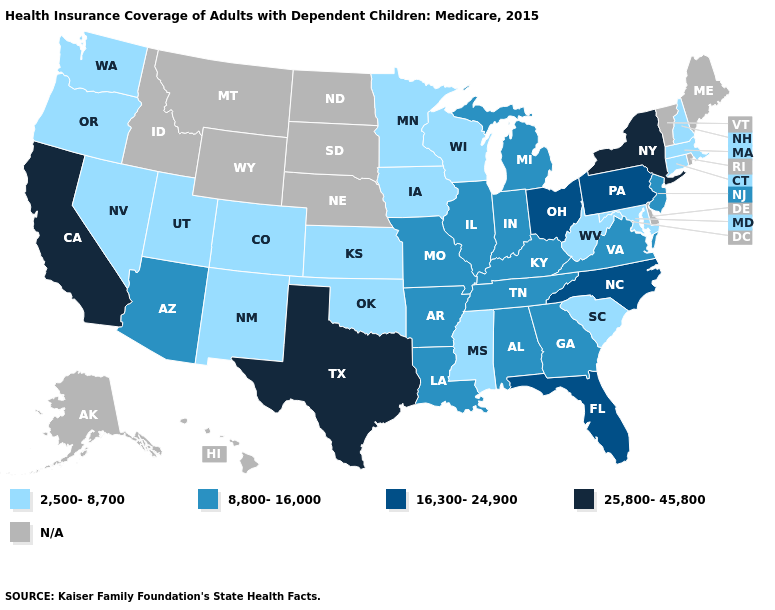How many symbols are there in the legend?
Give a very brief answer. 5. Among the states that border Utah , which have the highest value?
Short answer required. Arizona. Which states have the lowest value in the South?
Quick response, please. Maryland, Mississippi, Oklahoma, South Carolina, West Virginia. Name the states that have a value in the range N/A?
Keep it brief. Alaska, Delaware, Hawaii, Idaho, Maine, Montana, Nebraska, North Dakota, Rhode Island, South Dakota, Vermont, Wyoming. What is the value of West Virginia?
Write a very short answer. 2,500-8,700. What is the value of Colorado?
Quick response, please. 2,500-8,700. Which states have the lowest value in the USA?
Give a very brief answer. Colorado, Connecticut, Iowa, Kansas, Maryland, Massachusetts, Minnesota, Mississippi, Nevada, New Hampshire, New Mexico, Oklahoma, Oregon, South Carolina, Utah, Washington, West Virginia, Wisconsin. What is the value of Idaho?
Short answer required. N/A. Among the states that border Virginia , which have the highest value?
Write a very short answer. North Carolina. Which states hav the highest value in the West?
Short answer required. California. What is the value of Colorado?
Short answer required. 2,500-8,700. What is the value of Iowa?
Give a very brief answer. 2,500-8,700. Does New York have the highest value in the Northeast?
Concise answer only. Yes. Which states hav the highest value in the South?
Quick response, please. Texas. Name the states that have a value in the range N/A?
Keep it brief. Alaska, Delaware, Hawaii, Idaho, Maine, Montana, Nebraska, North Dakota, Rhode Island, South Dakota, Vermont, Wyoming. 